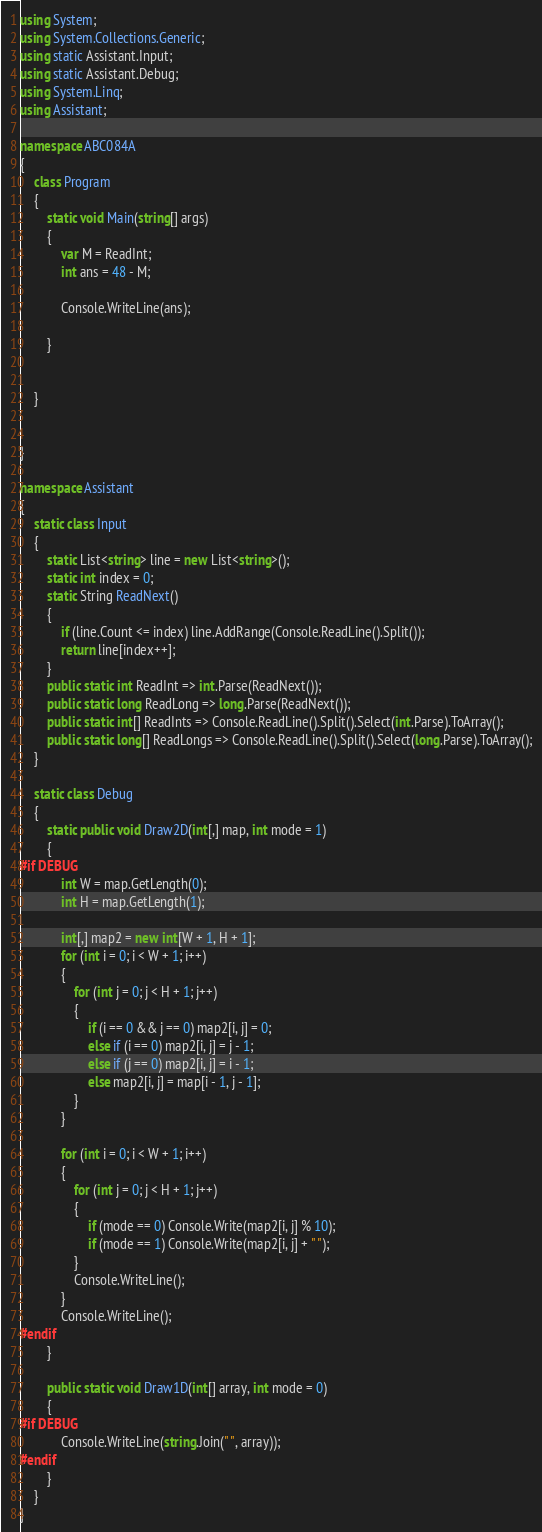<code> <loc_0><loc_0><loc_500><loc_500><_C#_>using System;
using System.Collections.Generic;
using static Assistant.Input;
using static Assistant.Debug;
using System.Linq;
using Assistant;

namespace ABC084A
{
    class Program
    {
        static void Main(string[] args)
        {
            var M = ReadInt;
            int ans = 48 - M;

            Console.WriteLine(ans);

        }


    }


}

namespace Assistant
{
    static class Input
    {
        static List<string> line = new List<string>();
        static int index = 0;
        static String ReadNext()
        {
            if (line.Count <= index) line.AddRange(Console.ReadLine().Split());
            return line[index++];
        }
        public static int ReadInt => int.Parse(ReadNext());
        public static long ReadLong => long.Parse(ReadNext());
        public static int[] ReadInts => Console.ReadLine().Split().Select(int.Parse).ToArray();
        public static long[] ReadLongs => Console.ReadLine().Split().Select(long.Parse).ToArray();
    }

    static class Debug
    {
        static public void Draw2D(int[,] map, int mode = 1)
        {
#if DEBUG
            int W = map.GetLength(0);
            int H = map.GetLength(1);

            int[,] map2 = new int[W + 1, H + 1];
            for (int i = 0; i < W + 1; i++)
            {
                for (int j = 0; j < H + 1; j++)
                {
                    if (i == 0 && j == 0) map2[i, j] = 0;
                    else if (i == 0) map2[i, j] = j - 1;
                    else if (j == 0) map2[i, j] = i - 1;
                    else map2[i, j] = map[i - 1, j - 1];
                }
            }

            for (int i = 0; i < W + 1; i++)
            {
                for (int j = 0; j < H + 1; j++)
                {
                    if (mode == 0) Console.Write(map2[i, j] % 10);
                    if (mode == 1) Console.Write(map2[i, j] + " ");
                }
                Console.WriteLine();
            }
            Console.WriteLine();
#endif
        }

        public static void Draw1D(int[] array, int mode = 0)
        {
#if DEBUG
            Console.WriteLine(string.Join(" ", array));
#endif
        }
    }
}
</code> 